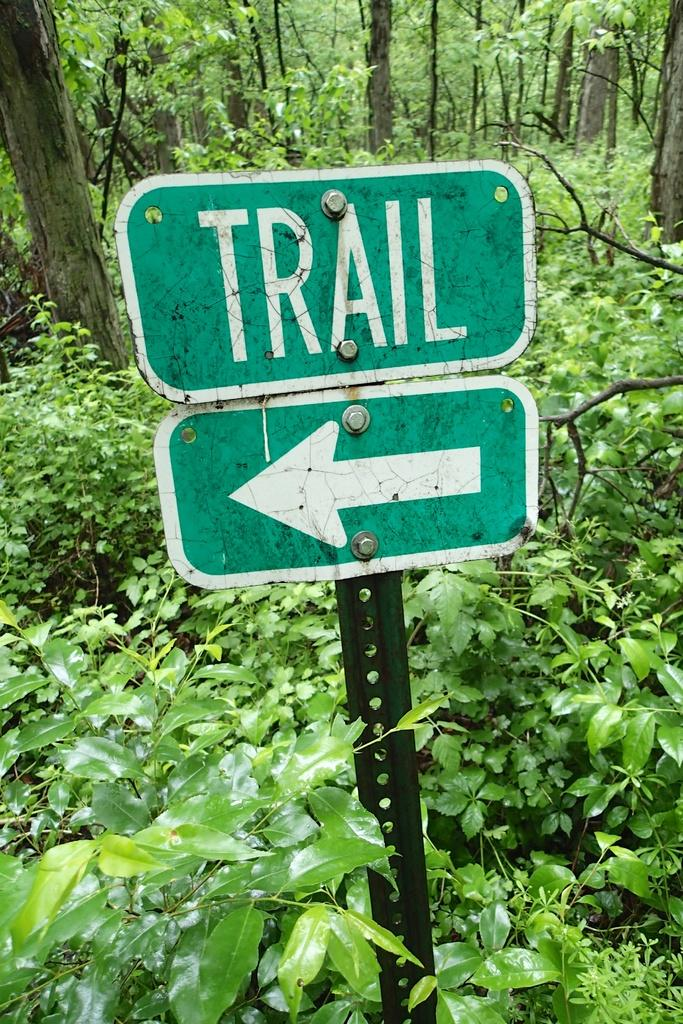<image>
Share a concise interpretation of the image provided. Trial with an arrow pointing left sign located in the forest. 